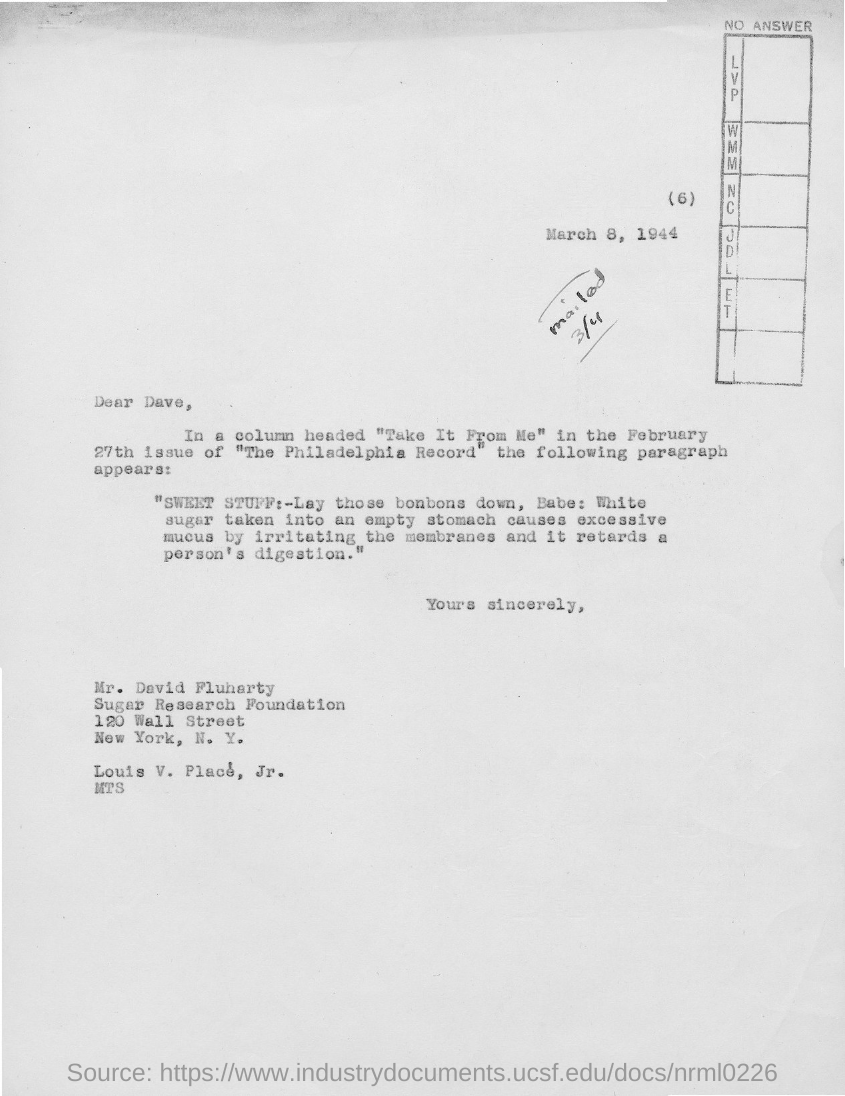What is the date mentioned?
Your answer should be very brief. March 8, 1944. To whom is the letter addressed to?
Your response must be concise. Dave. Which city is sugar research foudation in?
Give a very brief answer. New York. What is the column heading in the february 27th issue of " the philadelphia record"?
Offer a very short reply. "Take it from Me". 